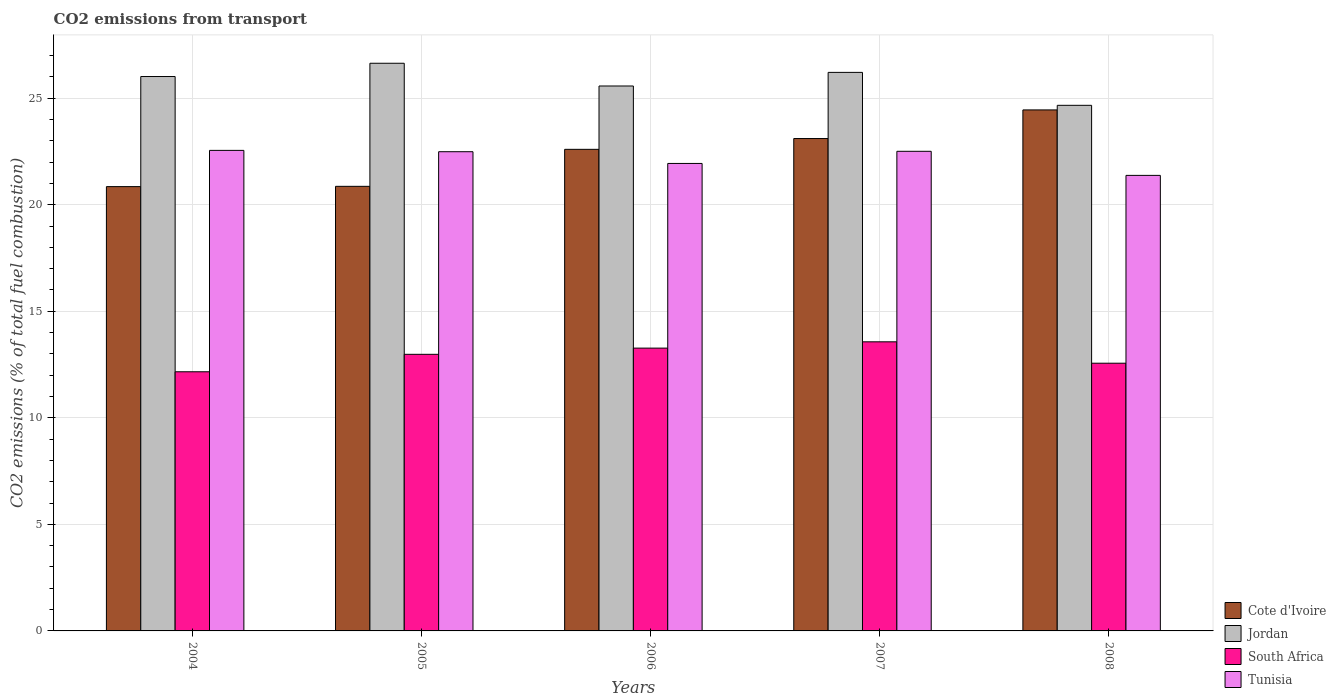How many different coloured bars are there?
Ensure brevity in your answer.  4. How many bars are there on the 2nd tick from the left?
Your answer should be very brief. 4. How many bars are there on the 2nd tick from the right?
Give a very brief answer. 4. What is the label of the 5th group of bars from the left?
Offer a terse response. 2008. What is the total CO2 emitted in South Africa in 2006?
Your answer should be compact. 13.27. Across all years, what is the maximum total CO2 emitted in Tunisia?
Your answer should be compact. 22.55. Across all years, what is the minimum total CO2 emitted in Cote d'Ivoire?
Your response must be concise. 20.85. In which year was the total CO2 emitted in Cote d'Ivoire maximum?
Make the answer very short. 2008. What is the total total CO2 emitted in Tunisia in the graph?
Provide a short and direct response. 110.85. What is the difference between the total CO2 emitted in Tunisia in 2004 and that in 2005?
Your answer should be very brief. 0.06. What is the difference between the total CO2 emitted in South Africa in 2008 and the total CO2 emitted in Tunisia in 2006?
Give a very brief answer. -9.37. What is the average total CO2 emitted in Jordan per year?
Provide a succinct answer. 25.82. In the year 2005, what is the difference between the total CO2 emitted in South Africa and total CO2 emitted in Jordan?
Ensure brevity in your answer.  -13.66. In how many years, is the total CO2 emitted in South Africa greater than 15?
Give a very brief answer. 0. What is the ratio of the total CO2 emitted in Jordan in 2004 to that in 2005?
Provide a succinct answer. 0.98. What is the difference between the highest and the second highest total CO2 emitted in Tunisia?
Offer a very short reply. 0.04. What is the difference between the highest and the lowest total CO2 emitted in South Africa?
Make the answer very short. 1.41. Is the sum of the total CO2 emitted in Tunisia in 2004 and 2005 greater than the maximum total CO2 emitted in South Africa across all years?
Your response must be concise. Yes. Is it the case that in every year, the sum of the total CO2 emitted in South Africa and total CO2 emitted in Cote d'Ivoire is greater than the sum of total CO2 emitted in Tunisia and total CO2 emitted in Jordan?
Make the answer very short. No. What does the 2nd bar from the left in 2007 represents?
Your answer should be very brief. Jordan. What does the 3rd bar from the right in 2007 represents?
Make the answer very short. Jordan. Is it the case that in every year, the sum of the total CO2 emitted in Cote d'Ivoire and total CO2 emitted in South Africa is greater than the total CO2 emitted in Tunisia?
Your answer should be very brief. Yes. How many bars are there?
Provide a short and direct response. 20. Are all the bars in the graph horizontal?
Keep it short and to the point. No. Does the graph contain any zero values?
Your response must be concise. No. Does the graph contain grids?
Offer a terse response. Yes. Where does the legend appear in the graph?
Make the answer very short. Bottom right. How many legend labels are there?
Ensure brevity in your answer.  4. What is the title of the graph?
Your answer should be compact. CO2 emissions from transport. What is the label or title of the Y-axis?
Give a very brief answer. CO2 emissions (% of total fuel combustion). What is the CO2 emissions (% of total fuel combustion) in Cote d'Ivoire in 2004?
Ensure brevity in your answer.  20.85. What is the CO2 emissions (% of total fuel combustion) in Jordan in 2004?
Offer a terse response. 26.01. What is the CO2 emissions (% of total fuel combustion) of South Africa in 2004?
Provide a short and direct response. 12.16. What is the CO2 emissions (% of total fuel combustion) of Tunisia in 2004?
Give a very brief answer. 22.55. What is the CO2 emissions (% of total fuel combustion) in Cote d'Ivoire in 2005?
Ensure brevity in your answer.  20.86. What is the CO2 emissions (% of total fuel combustion) of Jordan in 2005?
Keep it short and to the point. 26.64. What is the CO2 emissions (% of total fuel combustion) in South Africa in 2005?
Your response must be concise. 12.98. What is the CO2 emissions (% of total fuel combustion) of Tunisia in 2005?
Offer a terse response. 22.49. What is the CO2 emissions (% of total fuel combustion) in Cote d'Ivoire in 2006?
Give a very brief answer. 22.6. What is the CO2 emissions (% of total fuel combustion) in Jordan in 2006?
Provide a short and direct response. 25.57. What is the CO2 emissions (% of total fuel combustion) in South Africa in 2006?
Keep it short and to the point. 13.27. What is the CO2 emissions (% of total fuel combustion) of Tunisia in 2006?
Provide a short and direct response. 21.94. What is the CO2 emissions (% of total fuel combustion) of Cote d'Ivoire in 2007?
Your answer should be very brief. 23.1. What is the CO2 emissions (% of total fuel combustion) in Jordan in 2007?
Keep it short and to the point. 26.21. What is the CO2 emissions (% of total fuel combustion) of South Africa in 2007?
Your answer should be very brief. 13.57. What is the CO2 emissions (% of total fuel combustion) of Tunisia in 2007?
Offer a very short reply. 22.51. What is the CO2 emissions (% of total fuel combustion) of Cote d'Ivoire in 2008?
Your answer should be very brief. 24.45. What is the CO2 emissions (% of total fuel combustion) in Jordan in 2008?
Provide a short and direct response. 24.66. What is the CO2 emissions (% of total fuel combustion) in South Africa in 2008?
Keep it short and to the point. 12.56. What is the CO2 emissions (% of total fuel combustion) of Tunisia in 2008?
Make the answer very short. 21.38. Across all years, what is the maximum CO2 emissions (% of total fuel combustion) of Cote d'Ivoire?
Your answer should be very brief. 24.45. Across all years, what is the maximum CO2 emissions (% of total fuel combustion) in Jordan?
Make the answer very short. 26.64. Across all years, what is the maximum CO2 emissions (% of total fuel combustion) of South Africa?
Your answer should be compact. 13.57. Across all years, what is the maximum CO2 emissions (% of total fuel combustion) of Tunisia?
Keep it short and to the point. 22.55. Across all years, what is the minimum CO2 emissions (% of total fuel combustion) in Cote d'Ivoire?
Ensure brevity in your answer.  20.85. Across all years, what is the minimum CO2 emissions (% of total fuel combustion) of Jordan?
Provide a succinct answer. 24.66. Across all years, what is the minimum CO2 emissions (% of total fuel combustion) of South Africa?
Provide a succinct answer. 12.16. Across all years, what is the minimum CO2 emissions (% of total fuel combustion) in Tunisia?
Provide a succinct answer. 21.38. What is the total CO2 emissions (% of total fuel combustion) of Cote d'Ivoire in the graph?
Your answer should be compact. 111.86. What is the total CO2 emissions (% of total fuel combustion) of Jordan in the graph?
Offer a very short reply. 129.09. What is the total CO2 emissions (% of total fuel combustion) in South Africa in the graph?
Provide a short and direct response. 64.54. What is the total CO2 emissions (% of total fuel combustion) of Tunisia in the graph?
Provide a succinct answer. 110.85. What is the difference between the CO2 emissions (% of total fuel combustion) in Cote d'Ivoire in 2004 and that in 2005?
Offer a terse response. -0.01. What is the difference between the CO2 emissions (% of total fuel combustion) of Jordan in 2004 and that in 2005?
Your answer should be very brief. -0.62. What is the difference between the CO2 emissions (% of total fuel combustion) in South Africa in 2004 and that in 2005?
Keep it short and to the point. -0.82. What is the difference between the CO2 emissions (% of total fuel combustion) in Tunisia in 2004 and that in 2005?
Provide a short and direct response. 0.06. What is the difference between the CO2 emissions (% of total fuel combustion) in Cote d'Ivoire in 2004 and that in 2006?
Provide a succinct answer. -1.75. What is the difference between the CO2 emissions (% of total fuel combustion) of Jordan in 2004 and that in 2006?
Your answer should be compact. 0.44. What is the difference between the CO2 emissions (% of total fuel combustion) of South Africa in 2004 and that in 2006?
Keep it short and to the point. -1.11. What is the difference between the CO2 emissions (% of total fuel combustion) of Tunisia in 2004 and that in 2006?
Offer a terse response. 0.61. What is the difference between the CO2 emissions (% of total fuel combustion) of Cote d'Ivoire in 2004 and that in 2007?
Make the answer very short. -2.26. What is the difference between the CO2 emissions (% of total fuel combustion) in Jordan in 2004 and that in 2007?
Provide a succinct answer. -0.19. What is the difference between the CO2 emissions (% of total fuel combustion) of South Africa in 2004 and that in 2007?
Keep it short and to the point. -1.41. What is the difference between the CO2 emissions (% of total fuel combustion) in Tunisia in 2004 and that in 2007?
Keep it short and to the point. 0.04. What is the difference between the CO2 emissions (% of total fuel combustion) in Cote d'Ivoire in 2004 and that in 2008?
Provide a succinct answer. -3.6. What is the difference between the CO2 emissions (% of total fuel combustion) of Jordan in 2004 and that in 2008?
Your answer should be compact. 1.35. What is the difference between the CO2 emissions (% of total fuel combustion) in South Africa in 2004 and that in 2008?
Offer a terse response. -0.4. What is the difference between the CO2 emissions (% of total fuel combustion) in Tunisia in 2004 and that in 2008?
Provide a succinct answer. 1.17. What is the difference between the CO2 emissions (% of total fuel combustion) in Cote d'Ivoire in 2005 and that in 2006?
Make the answer very short. -1.74. What is the difference between the CO2 emissions (% of total fuel combustion) of Jordan in 2005 and that in 2006?
Offer a terse response. 1.07. What is the difference between the CO2 emissions (% of total fuel combustion) of South Africa in 2005 and that in 2006?
Provide a short and direct response. -0.29. What is the difference between the CO2 emissions (% of total fuel combustion) of Tunisia in 2005 and that in 2006?
Keep it short and to the point. 0.55. What is the difference between the CO2 emissions (% of total fuel combustion) in Cote d'Ivoire in 2005 and that in 2007?
Your answer should be compact. -2.24. What is the difference between the CO2 emissions (% of total fuel combustion) of Jordan in 2005 and that in 2007?
Provide a short and direct response. 0.43. What is the difference between the CO2 emissions (% of total fuel combustion) of South Africa in 2005 and that in 2007?
Your answer should be compact. -0.59. What is the difference between the CO2 emissions (% of total fuel combustion) in Tunisia in 2005 and that in 2007?
Make the answer very short. -0.02. What is the difference between the CO2 emissions (% of total fuel combustion) of Cote d'Ivoire in 2005 and that in 2008?
Your response must be concise. -3.59. What is the difference between the CO2 emissions (% of total fuel combustion) in Jordan in 2005 and that in 2008?
Ensure brevity in your answer.  1.97. What is the difference between the CO2 emissions (% of total fuel combustion) of South Africa in 2005 and that in 2008?
Your answer should be compact. 0.42. What is the difference between the CO2 emissions (% of total fuel combustion) of Tunisia in 2005 and that in 2008?
Provide a short and direct response. 1.11. What is the difference between the CO2 emissions (% of total fuel combustion) in Cote d'Ivoire in 2006 and that in 2007?
Ensure brevity in your answer.  -0.51. What is the difference between the CO2 emissions (% of total fuel combustion) of Jordan in 2006 and that in 2007?
Make the answer very short. -0.64. What is the difference between the CO2 emissions (% of total fuel combustion) in South Africa in 2006 and that in 2007?
Provide a succinct answer. -0.3. What is the difference between the CO2 emissions (% of total fuel combustion) in Tunisia in 2006 and that in 2007?
Offer a very short reply. -0.57. What is the difference between the CO2 emissions (% of total fuel combustion) of Cote d'Ivoire in 2006 and that in 2008?
Provide a short and direct response. -1.85. What is the difference between the CO2 emissions (% of total fuel combustion) of Jordan in 2006 and that in 2008?
Offer a terse response. 0.91. What is the difference between the CO2 emissions (% of total fuel combustion) in South Africa in 2006 and that in 2008?
Make the answer very short. 0.71. What is the difference between the CO2 emissions (% of total fuel combustion) in Tunisia in 2006 and that in 2008?
Your answer should be compact. 0.56. What is the difference between the CO2 emissions (% of total fuel combustion) in Cote d'Ivoire in 2007 and that in 2008?
Offer a very short reply. -1.34. What is the difference between the CO2 emissions (% of total fuel combustion) of Jordan in 2007 and that in 2008?
Provide a succinct answer. 1.55. What is the difference between the CO2 emissions (% of total fuel combustion) in South Africa in 2007 and that in 2008?
Make the answer very short. 1. What is the difference between the CO2 emissions (% of total fuel combustion) of Tunisia in 2007 and that in 2008?
Provide a succinct answer. 1.13. What is the difference between the CO2 emissions (% of total fuel combustion) in Cote d'Ivoire in 2004 and the CO2 emissions (% of total fuel combustion) in Jordan in 2005?
Your answer should be very brief. -5.79. What is the difference between the CO2 emissions (% of total fuel combustion) of Cote d'Ivoire in 2004 and the CO2 emissions (% of total fuel combustion) of South Africa in 2005?
Ensure brevity in your answer.  7.87. What is the difference between the CO2 emissions (% of total fuel combustion) in Cote d'Ivoire in 2004 and the CO2 emissions (% of total fuel combustion) in Tunisia in 2005?
Provide a succinct answer. -1.64. What is the difference between the CO2 emissions (% of total fuel combustion) of Jordan in 2004 and the CO2 emissions (% of total fuel combustion) of South Africa in 2005?
Offer a very short reply. 13.04. What is the difference between the CO2 emissions (% of total fuel combustion) in Jordan in 2004 and the CO2 emissions (% of total fuel combustion) in Tunisia in 2005?
Make the answer very short. 3.53. What is the difference between the CO2 emissions (% of total fuel combustion) in South Africa in 2004 and the CO2 emissions (% of total fuel combustion) in Tunisia in 2005?
Give a very brief answer. -10.33. What is the difference between the CO2 emissions (% of total fuel combustion) in Cote d'Ivoire in 2004 and the CO2 emissions (% of total fuel combustion) in Jordan in 2006?
Provide a succinct answer. -4.72. What is the difference between the CO2 emissions (% of total fuel combustion) of Cote d'Ivoire in 2004 and the CO2 emissions (% of total fuel combustion) of South Africa in 2006?
Ensure brevity in your answer.  7.58. What is the difference between the CO2 emissions (% of total fuel combustion) of Cote d'Ivoire in 2004 and the CO2 emissions (% of total fuel combustion) of Tunisia in 2006?
Your answer should be very brief. -1.09. What is the difference between the CO2 emissions (% of total fuel combustion) in Jordan in 2004 and the CO2 emissions (% of total fuel combustion) in South Africa in 2006?
Offer a very short reply. 12.74. What is the difference between the CO2 emissions (% of total fuel combustion) of Jordan in 2004 and the CO2 emissions (% of total fuel combustion) of Tunisia in 2006?
Give a very brief answer. 4.08. What is the difference between the CO2 emissions (% of total fuel combustion) in South Africa in 2004 and the CO2 emissions (% of total fuel combustion) in Tunisia in 2006?
Offer a very short reply. -9.78. What is the difference between the CO2 emissions (% of total fuel combustion) in Cote d'Ivoire in 2004 and the CO2 emissions (% of total fuel combustion) in Jordan in 2007?
Your response must be concise. -5.36. What is the difference between the CO2 emissions (% of total fuel combustion) of Cote d'Ivoire in 2004 and the CO2 emissions (% of total fuel combustion) of South Africa in 2007?
Provide a short and direct response. 7.28. What is the difference between the CO2 emissions (% of total fuel combustion) in Cote d'Ivoire in 2004 and the CO2 emissions (% of total fuel combustion) in Tunisia in 2007?
Provide a succinct answer. -1.66. What is the difference between the CO2 emissions (% of total fuel combustion) of Jordan in 2004 and the CO2 emissions (% of total fuel combustion) of South Africa in 2007?
Provide a succinct answer. 12.45. What is the difference between the CO2 emissions (% of total fuel combustion) in Jordan in 2004 and the CO2 emissions (% of total fuel combustion) in Tunisia in 2007?
Provide a short and direct response. 3.51. What is the difference between the CO2 emissions (% of total fuel combustion) of South Africa in 2004 and the CO2 emissions (% of total fuel combustion) of Tunisia in 2007?
Make the answer very short. -10.35. What is the difference between the CO2 emissions (% of total fuel combustion) of Cote d'Ivoire in 2004 and the CO2 emissions (% of total fuel combustion) of Jordan in 2008?
Give a very brief answer. -3.81. What is the difference between the CO2 emissions (% of total fuel combustion) of Cote d'Ivoire in 2004 and the CO2 emissions (% of total fuel combustion) of South Africa in 2008?
Offer a very short reply. 8.29. What is the difference between the CO2 emissions (% of total fuel combustion) in Cote d'Ivoire in 2004 and the CO2 emissions (% of total fuel combustion) in Tunisia in 2008?
Your response must be concise. -0.53. What is the difference between the CO2 emissions (% of total fuel combustion) of Jordan in 2004 and the CO2 emissions (% of total fuel combustion) of South Africa in 2008?
Provide a succinct answer. 13.45. What is the difference between the CO2 emissions (% of total fuel combustion) in Jordan in 2004 and the CO2 emissions (% of total fuel combustion) in Tunisia in 2008?
Keep it short and to the point. 4.64. What is the difference between the CO2 emissions (% of total fuel combustion) in South Africa in 2004 and the CO2 emissions (% of total fuel combustion) in Tunisia in 2008?
Provide a short and direct response. -9.21. What is the difference between the CO2 emissions (% of total fuel combustion) of Cote d'Ivoire in 2005 and the CO2 emissions (% of total fuel combustion) of Jordan in 2006?
Ensure brevity in your answer.  -4.71. What is the difference between the CO2 emissions (% of total fuel combustion) in Cote d'Ivoire in 2005 and the CO2 emissions (% of total fuel combustion) in South Africa in 2006?
Give a very brief answer. 7.59. What is the difference between the CO2 emissions (% of total fuel combustion) in Cote d'Ivoire in 2005 and the CO2 emissions (% of total fuel combustion) in Tunisia in 2006?
Your answer should be compact. -1.07. What is the difference between the CO2 emissions (% of total fuel combustion) in Jordan in 2005 and the CO2 emissions (% of total fuel combustion) in South Africa in 2006?
Offer a terse response. 13.37. What is the difference between the CO2 emissions (% of total fuel combustion) of Jordan in 2005 and the CO2 emissions (% of total fuel combustion) of Tunisia in 2006?
Give a very brief answer. 4.7. What is the difference between the CO2 emissions (% of total fuel combustion) in South Africa in 2005 and the CO2 emissions (% of total fuel combustion) in Tunisia in 2006?
Your response must be concise. -8.96. What is the difference between the CO2 emissions (% of total fuel combustion) of Cote d'Ivoire in 2005 and the CO2 emissions (% of total fuel combustion) of Jordan in 2007?
Provide a succinct answer. -5.35. What is the difference between the CO2 emissions (% of total fuel combustion) in Cote d'Ivoire in 2005 and the CO2 emissions (% of total fuel combustion) in South Africa in 2007?
Give a very brief answer. 7.3. What is the difference between the CO2 emissions (% of total fuel combustion) of Cote d'Ivoire in 2005 and the CO2 emissions (% of total fuel combustion) of Tunisia in 2007?
Provide a succinct answer. -1.64. What is the difference between the CO2 emissions (% of total fuel combustion) in Jordan in 2005 and the CO2 emissions (% of total fuel combustion) in South Africa in 2007?
Your answer should be compact. 13.07. What is the difference between the CO2 emissions (% of total fuel combustion) of Jordan in 2005 and the CO2 emissions (% of total fuel combustion) of Tunisia in 2007?
Your answer should be very brief. 4.13. What is the difference between the CO2 emissions (% of total fuel combustion) in South Africa in 2005 and the CO2 emissions (% of total fuel combustion) in Tunisia in 2007?
Offer a terse response. -9.53. What is the difference between the CO2 emissions (% of total fuel combustion) in Cote d'Ivoire in 2005 and the CO2 emissions (% of total fuel combustion) in Jordan in 2008?
Ensure brevity in your answer.  -3.8. What is the difference between the CO2 emissions (% of total fuel combustion) in Cote d'Ivoire in 2005 and the CO2 emissions (% of total fuel combustion) in South Africa in 2008?
Your answer should be compact. 8.3. What is the difference between the CO2 emissions (% of total fuel combustion) in Cote d'Ivoire in 2005 and the CO2 emissions (% of total fuel combustion) in Tunisia in 2008?
Offer a terse response. -0.51. What is the difference between the CO2 emissions (% of total fuel combustion) of Jordan in 2005 and the CO2 emissions (% of total fuel combustion) of South Africa in 2008?
Give a very brief answer. 14.07. What is the difference between the CO2 emissions (% of total fuel combustion) in Jordan in 2005 and the CO2 emissions (% of total fuel combustion) in Tunisia in 2008?
Provide a short and direct response. 5.26. What is the difference between the CO2 emissions (% of total fuel combustion) of South Africa in 2005 and the CO2 emissions (% of total fuel combustion) of Tunisia in 2008?
Provide a succinct answer. -8.4. What is the difference between the CO2 emissions (% of total fuel combustion) in Cote d'Ivoire in 2006 and the CO2 emissions (% of total fuel combustion) in Jordan in 2007?
Your answer should be compact. -3.61. What is the difference between the CO2 emissions (% of total fuel combustion) in Cote d'Ivoire in 2006 and the CO2 emissions (% of total fuel combustion) in South Africa in 2007?
Offer a terse response. 9.03. What is the difference between the CO2 emissions (% of total fuel combustion) of Cote d'Ivoire in 2006 and the CO2 emissions (% of total fuel combustion) of Tunisia in 2007?
Provide a succinct answer. 0.09. What is the difference between the CO2 emissions (% of total fuel combustion) in Jordan in 2006 and the CO2 emissions (% of total fuel combustion) in South Africa in 2007?
Make the answer very short. 12. What is the difference between the CO2 emissions (% of total fuel combustion) in Jordan in 2006 and the CO2 emissions (% of total fuel combustion) in Tunisia in 2007?
Your answer should be compact. 3.06. What is the difference between the CO2 emissions (% of total fuel combustion) of South Africa in 2006 and the CO2 emissions (% of total fuel combustion) of Tunisia in 2007?
Your response must be concise. -9.24. What is the difference between the CO2 emissions (% of total fuel combustion) of Cote d'Ivoire in 2006 and the CO2 emissions (% of total fuel combustion) of Jordan in 2008?
Offer a terse response. -2.07. What is the difference between the CO2 emissions (% of total fuel combustion) of Cote d'Ivoire in 2006 and the CO2 emissions (% of total fuel combustion) of South Africa in 2008?
Provide a succinct answer. 10.04. What is the difference between the CO2 emissions (% of total fuel combustion) of Cote d'Ivoire in 2006 and the CO2 emissions (% of total fuel combustion) of Tunisia in 2008?
Your response must be concise. 1.22. What is the difference between the CO2 emissions (% of total fuel combustion) of Jordan in 2006 and the CO2 emissions (% of total fuel combustion) of South Africa in 2008?
Your response must be concise. 13.01. What is the difference between the CO2 emissions (% of total fuel combustion) in Jordan in 2006 and the CO2 emissions (% of total fuel combustion) in Tunisia in 2008?
Your answer should be compact. 4.19. What is the difference between the CO2 emissions (% of total fuel combustion) of South Africa in 2006 and the CO2 emissions (% of total fuel combustion) of Tunisia in 2008?
Your response must be concise. -8.11. What is the difference between the CO2 emissions (% of total fuel combustion) of Cote d'Ivoire in 2007 and the CO2 emissions (% of total fuel combustion) of Jordan in 2008?
Make the answer very short. -1.56. What is the difference between the CO2 emissions (% of total fuel combustion) of Cote d'Ivoire in 2007 and the CO2 emissions (% of total fuel combustion) of South Africa in 2008?
Make the answer very short. 10.54. What is the difference between the CO2 emissions (% of total fuel combustion) of Cote d'Ivoire in 2007 and the CO2 emissions (% of total fuel combustion) of Tunisia in 2008?
Your response must be concise. 1.73. What is the difference between the CO2 emissions (% of total fuel combustion) of Jordan in 2007 and the CO2 emissions (% of total fuel combustion) of South Africa in 2008?
Offer a terse response. 13.65. What is the difference between the CO2 emissions (% of total fuel combustion) of Jordan in 2007 and the CO2 emissions (% of total fuel combustion) of Tunisia in 2008?
Offer a terse response. 4.83. What is the difference between the CO2 emissions (% of total fuel combustion) in South Africa in 2007 and the CO2 emissions (% of total fuel combustion) in Tunisia in 2008?
Keep it short and to the point. -7.81. What is the average CO2 emissions (% of total fuel combustion) in Cote d'Ivoire per year?
Make the answer very short. 22.37. What is the average CO2 emissions (% of total fuel combustion) in Jordan per year?
Keep it short and to the point. 25.82. What is the average CO2 emissions (% of total fuel combustion) in South Africa per year?
Make the answer very short. 12.91. What is the average CO2 emissions (% of total fuel combustion) in Tunisia per year?
Your answer should be very brief. 22.17. In the year 2004, what is the difference between the CO2 emissions (% of total fuel combustion) in Cote d'Ivoire and CO2 emissions (% of total fuel combustion) in Jordan?
Your answer should be very brief. -5.17. In the year 2004, what is the difference between the CO2 emissions (% of total fuel combustion) in Cote d'Ivoire and CO2 emissions (% of total fuel combustion) in South Africa?
Make the answer very short. 8.69. In the year 2004, what is the difference between the CO2 emissions (% of total fuel combustion) in Cote d'Ivoire and CO2 emissions (% of total fuel combustion) in Tunisia?
Offer a very short reply. -1.7. In the year 2004, what is the difference between the CO2 emissions (% of total fuel combustion) of Jordan and CO2 emissions (% of total fuel combustion) of South Africa?
Offer a very short reply. 13.85. In the year 2004, what is the difference between the CO2 emissions (% of total fuel combustion) of Jordan and CO2 emissions (% of total fuel combustion) of Tunisia?
Your answer should be very brief. 3.47. In the year 2004, what is the difference between the CO2 emissions (% of total fuel combustion) of South Africa and CO2 emissions (% of total fuel combustion) of Tunisia?
Ensure brevity in your answer.  -10.39. In the year 2005, what is the difference between the CO2 emissions (% of total fuel combustion) of Cote d'Ivoire and CO2 emissions (% of total fuel combustion) of Jordan?
Offer a terse response. -5.78. In the year 2005, what is the difference between the CO2 emissions (% of total fuel combustion) in Cote d'Ivoire and CO2 emissions (% of total fuel combustion) in South Africa?
Give a very brief answer. 7.88. In the year 2005, what is the difference between the CO2 emissions (% of total fuel combustion) of Cote d'Ivoire and CO2 emissions (% of total fuel combustion) of Tunisia?
Offer a very short reply. -1.62. In the year 2005, what is the difference between the CO2 emissions (% of total fuel combustion) in Jordan and CO2 emissions (% of total fuel combustion) in South Africa?
Provide a short and direct response. 13.66. In the year 2005, what is the difference between the CO2 emissions (% of total fuel combustion) in Jordan and CO2 emissions (% of total fuel combustion) in Tunisia?
Your answer should be very brief. 4.15. In the year 2005, what is the difference between the CO2 emissions (% of total fuel combustion) in South Africa and CO2 emissions (% of total fuel combustion) in Tunisia?
Offer a terse response. -9.51. In the year 2006, what is the difference between the CO2 emissions (% of total fuel combustion) of Cote d'Ivoire and CO2 emissions (% of total fuel combustion) of Jordan?
Your response must be concise. -2.97. In the year 2006, what is the difference between the CO2 emissions (% of total fuel combustion) of Cote d'Ivoire and CO2 emissions (% of total fuel combustion) of South Africa?
Provide a succinct answer. 9.33. In the year 2006, what is the difference between the CO2 emissions (% of total fuel combustion) in Cote d'Ivoire and CO2 emissions (% of total fuel combustion) in Tunisia?
Your answer should be compact. 0.66. In the year 2006, what is the difference between the CO2 emissions (% of total fuel combustion) in Jordan and CO2 emissions (% of total fuel combustion) in South Africa?
Provide a succinct answer. 12.3. In the year 2006, what is the difference between the CO2 emissions (% of total fuel combustion) in Jordan and CO2 emissions (% of total fuel combustion) in Tunisia?
Your response must be concise. 3.63. In the year 2006, what is the difference between the CO2 emissions (% of total fuel combustion) of South Africa and CO2 emissions (% of total fuel combustion) of Tunisia?
Offer a terse response. -8.67. In the year 2007, what is the difference between the CO2 emissions (% of total fuel combustion) of Cote d'Ivoire and CO2 emissions (% of total fuel combustion) of Jordan?
Give a very brief answer. -3.1. In the year 2007, what is the difference between the CO2 emissions (% of total fuel combustion) of Cote d'Ivoire and CO2 emissions (% of total fuel combustion) of South Africa?
Keep it short and to the point. 9.54. In the year 2007, what is the difference between the CO2 emissions (% of total fuel combustion) in Cote d'Ivoire and CO2 emissions (% of total fuel combustion) in Tunisia?
Make the answer very short. 0.6. In the year 2007, what is the difference between the CO2 emissions (% of total fuel combustion) in Jordan and CO2 emissions (% of total fuel combustion) in South Africa?
Give a very brief answer. 12.64. In the year 2007, what is the difference between the CO2 emissions (% of total fuel combustion) in Jordan and CO2 emissions (% of total fuel combustion) in Tunisia?
Your answer should be compact. 3.7. In the year 2007, what is the difference between the CO2 emissions (% of total fuel combustion) in South Africa and CO2 emissions (% of total fuel combustion) in Tunisia?
Keep it short and to the point. -8.94. In the year 2008, what is the difference between the CO2 emissions (% of total fuel combustion) of Cote d'Ivoire and CO2 emissions (% of total fuel combustion) of Jordan?
Your answer should be compact. -0.22. In the year 2008, what is the difference between the CO2 emissions (% of total fuel combustion) in Cote d'Ivoire and CO2 emissions (% of total fuel combustion) in South Africa?
Make the answer very short. 11.89. In the year 2008, what is the difference between the CO2 emissions (% of total fuel combustion) of Cote d'Ivoire and CO2 emissions (% of total fuel combustion) of Tunisia?
Offer a terse response. 3.07. In the year 2008, what is the difference between the CO2 emissions (% of total fuel combustion) in Jordan and CO2 emissions (% of total fuel combustion) in South Africa?
Make the answer very short. 12.1. In the year 2008, what is the difference between the CO2 emissions (% of total fuel combustion) in Jordan and CO2 emissions (% of total fuel combustion) in Tunisia?
Your answer should be compact. 3.29. In the year 2008, what is the difference between the CO2 emissions (% of total fuel combustion) in South Africa and CO2 emissions (% of total fuel combustion) in Tunisia?
Your answer should be compact. -8.81. What is the ratio of the CO2 emissions (% of total fuel combustion) in Cote d'Ivoire in 2004 to that in 2005?
Offer a terse response. 1. What is the ratio of the CO2 emissions (% of total fuel combustion) of Jordan in 2004 to that in 2005?
Make the answer very short. 0.98. What is the ratio of the CO2 emissions (% of total fuel combustion) in South Africa in 2004 to that in 2005?
Ensure brevity in your answer.  0.94. What is the ratio of the CO2 emissions (% of total fuel combustion) of Cote d'Ivoire in 2004 to that in 2006?
Your response must be concise. 0.92. What is the ratio of the CO2 emissions (% of total fuel combustion) in Jordan in 2004 to that in 2006?
Offer a terse response. 1.02. What is the ratio of the CO2 emissions (% of total fuel combustion) in South Africa in 2004 to that in 2006?
Keep it short and to the point. 0.92. What is the ratio of the CO2 emissions (% of total fuel combustion) of Tunisia in 2004 to that in 2006?
Give a very brief answer. 1.03. What is the ratio of the CO2 emissions (% of total fuel combustion) of Cote d'Ivoire in 2004 to that in 2007?
Your response must be concise. 0.9. What is the ratio of the CO2 emissions (% of total fuel combustion) in Jordan in 2004 to that in 2007?
Offer a terse response. 0.99. What is the ratio of the CO2 emissions (% of total fuel combustion) of South Africa in 2004 to that in 2007?
Offer a terse response. 0.9. What is the ratio of the CO2 emissions (% of total fuel combustion) in Tunisia in 2004 to that in 2007?
Give a very brief answer. 1. What is the ratio of the CO2 emissions (% of total fuel combustion) of Cote d'Ivoire in 2004 to that in 2008?
Your response must be concise. 0.85. What is the ratio of the CO2 emissions (% of total fuel combustion) of Jordan in 2004 to that in 2008?
Offer a terse response. 1.05. What is the ratio of the CO2 emissions (% of total fuel combustion) in South Africa in 2004 to that in 2008?
Provide a short and direct response. 0.97. What is the ratio of the CO2 emissions (% of total fuel combustion) of Tunisia in 2004 to that in 2008?
Provide a succinct answer. 1.05. What is the ratio of the CO2 emissions (% of total fuel combustion) of Cote d'Ivoire in 2005 to that in 2006?
Your answer should be very brief. 0.92. What is the ratio of the CO2 emissions (% of total fuel combustion) in Jordan in 2005 to that in 2006?
Provide a short and direct response. 1.04. What is the ratio of the CO2 emissions (% of total fuel combustion) in South Africa in 2005 to that in 2006?
Your response must be concise. 0.98. What is the ratio of the CO2 emissions (% of total fuel combustion) of Tunisia in 2005 to that in 2006?
Offer a very short reply. 1.03. What is the ratio of the CO2 emissions (% of total fuel combustion) in Cote d'Ivoire in 2005 to that in 2007?
Offer a terse response. 0.9. What is the ratio of the CO2 emissions (% of total fuel combustion) of Jordan in 2005 to that in 2007?
Ensure brevity in your answer.  1.02. What is the ratio of the CO2 emissions (% of total fuel combustion) in South Africa in 2005 to that in 2007?
Ensure brevity in your answer.  0.96. What is the ratio of the CO2 emissions (% of total fuel combustion) in Tunisia in 2005 to that in 2007?
Keep it short and to the point. 1. What is the ratio of the CO2 emissions (% of total fuel combustion) of Cote d'Ivoire in 2005 to that in 2008?
Your answer should be very brief. 0.85. What is the ratio of the CO2 emissions (% of total fuel combustion) of South Africa in 2005 to that in 2008?
Give a very brief answer. 1.03. What is the ratio of the CO2 emissions (% of total fuel combustion) in Tunisia in 2005 to that in 2008?
Keep it short and to the point. 1.05. What is the ratio of the CO2 emissions (% of total fuel combustion) of Cote d'Ivoire in 2006 to that in 2007?
Keep it short and to the point. 0.98. What is the ratio of the CO2 emissions (% of total fuel combustion) of Jordan in 2006 to that in 2007?
Provide a succinct answer. 0.98. What is the ratio of the CO2 emissions (% of total fuel combustion) in South Africa in 2006 to that in 2007?
Your answer should be very brief. 0.98. What is the ratio of the CO2 emissions (% of total fuel combustion) of Tunisia in 2006 to that in 2007?
Keep it short and to the point. 0.97. What is the ratio of the CO2 emissions (% of total fuel combustion) of Cote d'Ivoire in 2006 to that in 2008?
Provide a short and direct response. 0.92. What is the ratio of the CO2 emissions (% of total fuel combustion) in Jordan in 2006 to that in 2008?
Your response must be concise. 1.04. What is the ratio of the CO2 emissions (% of total fuel combustion) in South Africa in 2006 to that in 2008?
Give a very brief answer. 1.06. What is the ratio of the CO2 emissions (% of total fuel combustion) of Tunisia in 2006 to that in 2008?
Your answer should be very brief. 1.03. What is the ratio of the CO2 emissions (% of total fuel combustion) in Cote d'Ivoire in 2007 to that in 2008?
Your answer should be compact. 0.95. What is the ratio of the CO2 emissions (% of total fuel combustion) in Jordan in 2007 to that in 2008?
Offer a very short reply. 1.06. What is the ratio of the CO2 emissions (% of total fuel combustion) of South Africa in 2007 to that in 2008?
Provide a succinct answer. 1.08. What is the ratio of the CO2 emissions (% of total fuel combustion) of Tunisia in 2007 to that in 2008?
Give a very brief answer. 1.05. What is the difference between the highest and the second highest CO2 emissions (% of total fuel combustion) of Cote d'Ivoire?
Provide a short and direct response. 1.34. What is the difference between the highest and the second highest CO2 emissions (% of total fuel combustion) in Jordan?
Offer a very short reply. 0.43. What is the difference between the highest and the second highest CO2 emissions (% of total fuel combustion) in South Africa?
Offer a terse response. 0.3. What is the difference between the highest and the second highest CO2 emissions (% of total fuel combustion) in Tunisia?
Give a very brief answer. 0.04. What is the difference between the highest and the lowest CO2 emissions (% of total fuel combustion) of Cote d'Ivoire?
Provide a succinct answer. 3.6. What is the difference between the highest and the lowest CO2 emissions (% of total fuel combustion) of Jordan?
Your answer should be very brief. 1.97. What is the difference between the highest and the lowest CO2 emissions (% of total fuel combustion) in South Africa?
Your answer should be compact. 1.41. What is the difference between the highest and the lowest CO2 emissions (% of total fuel combustion) of Tunisia?
Ensure brevity in your answer.  1.17. 